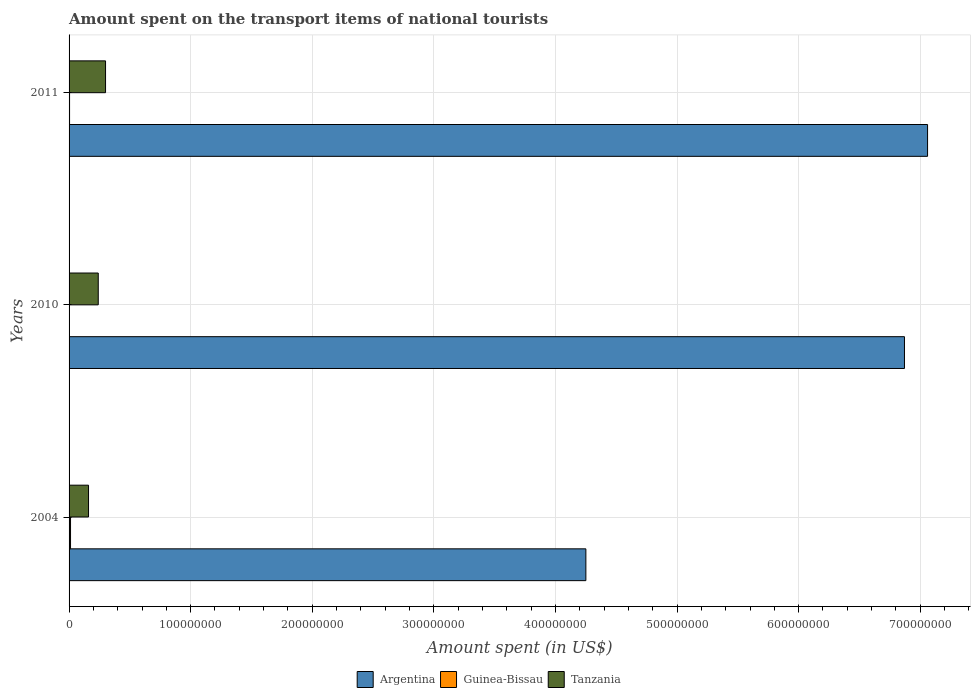How many different coloured bars are there?
Your answer should be compact. 3. Are the number of bars per tick equal to the number of legend labels?
Provide a short and direct response. Yes. Are the number of bars on each tick of the Y-axis equal?
Provide a short and direct response. Yes. How many bars are there on the 2nd tick from the top?
Keep it short and to the point. 3. What is the amount spent on the transport items of national tourists in Argentina in 2004?
Offer a terse response. 4.25e+08. Across all years, what is the maximum amount spent on the transport items of national tourists in Guinea-Bissau?
Your answer should be compact. 1.20e+06. Across all years, what is the minimum amount spent on the transport items of national tourists in Tanzania?
Your response must be concise. 1.60e+07. In which year was the amount spent on the transport items of national tourists in Argentina minimum?
Offer a terse response. 2004. What is the total amount spent on the transport items of national tourists in Guinea-Bissau in the graph?
Your response must be concise. 1.90e+06. What is the difference between the amount spent on the transport items of national tourists in Guinea-Bissau in 2004 and that in 2010?
Your response must be concise. 9.00e+05. What is the difference between the amount spent on the transport items of national tourists in Guinea-Bissau in 2010 and the amount spent on the transport items of national tourists in Tanzania in 2011?
Offer a terse response. -2.97e+07. What is the average amount spent on the transport items of national tourists in Guinea-Bissau per year?
Give a very brief answer. 6.33e+05. In the year 2004, what is the difference between the amount spent on the transport items of national tourists in Guinea-Bissau and amount spent on the transport items of national tourists in Argentina?
Your response must be concise. -4.24e+08. In how many years, is the amount spent on the transport items of national tourists in Argentina greater than 280000000 US$?
Provide a short and direct response. 3. What is the difference between the highest and the second highest amount spent on the transport items of national tourists in Argentina?
Provide a succinct answer. 1.90e+07. What is the difference between the highest and the lowest amount spent on the transport items of national tourists in Argentina?
Provide a short and direct response. 2.81e+08. In how many years, is the amount spent on the transport items of national tourists in Tanzania greater than the average amount spent on the transport items of national tourists in Tanzania taken over all years?
Offer a terse response. 2. Is the sum of the amount spent on the transport items of national tourists in Tanzania in 2004 and 2010 greater than the maximum amount spent on the transport items of national tourists in Argentina across all years?
Your response must be concise. No. What does the 2nd bar from the bottom in 2011 represents?
Your answer should be compact. Guinea-Bissau. Is it the case that in every year, the sum of the amount spent on the transport items of national tourists in Argentina and amount spent on the transport items of national tourists in Guinea-Bissau is greater than the amount spent on the transport items of national tourists in Tanzania?
Your answer should be compact. Yes. Are all the bars in the graph horizontal?
Keep it short and to the point. Yes. How many years are there in the graph?
Provide a succinct answer. 3. What is the difference between two consecutive major ticks on the X-axis?
Make the answer very short. 1.00e+08. Are the values on the major ticks of X-axis written in scientific E-notation?
Your answer should be compact. No. How many legend labels are there?
Provide a short and direct response. 3. What is the title of the graph?
Provide a short and direct response. Amount spent on the transport items of national tourists. Does "Zambia" appear as one of the legend labels in the graph?
Make the answer very short. No. What is the label or title of the X-axis?
Offer a very short reply. Amount spent (in US$). What is the Amount spent (in US$) in Argentina in 2004?
Provide a succinct answer. 4.25e+08. What is the Amount spent (in US$) of Guinea-Bissau in 2004?
Ensure brevity in your answer.  1.20e+06. What is the Amount spent (in US$) of Tanzania in 2004?
Your response must be concise. 1.60e+07. What is the Amount spent (in US$) of Argentina in 2010?
Keep it short and to the point. 6.87e+08. What is the Amount spent (in US$) of Tanzania in 2010?
Your answer should be compact. 2.40e+07. What is the Amount spent (in US$) in Argentina in 2011?
Offer a terse response. 7.06e+08. What is the Amount spent (in US$) of Tanzania in 2011?
Make the answer very short. 3.00e+07. Across all years, what is the maximum Amount spent (in US$) of Argentina?
Offer a terse response. 7.06e+08. Across all years, what is the maximum Amount spent (in US$) of Guinea-Bissau?
Make the answer very short. 1.20e+06. Across all years, what is the maximum Amount spent (in US$) of Tanzania?
Your response must be concise. 3.00e+07. Across all years, what is the minimum Amount spent (in US$) in Argentina?
Give a very brief answer. 4.25e+08. Across all years, what is the minimum Amount spent (in US$) of Tanzania?
Make the answer very short. 1.60e+07. What is the total Amount spent (in US$) in Argentina in the graph?
Your answer should be very brief. 1.82e+09. What is the total Amount spent (in US$) of Guinea-Bissau in the graph?
Your response must be concise. 1.90e+06. What is the total Amount spent (in US$) in Tanzania in the graph?
Offer a very short reply. 7.00e+07. What is the difference between the Amount spent (in US$) of Argentina in 2004 and that in 2010?
Your response must be concise. -2.62e+08. What is the difference between the Amount spent (in US$) of Tanzania in 2004 and that in 2010?
Your answer should be very brief. -8.00e+06. What is the difference between the Amount spent (in US$) of Argentina in 2004 and that in 2011?
Offer a terse response. -2.81e+08. What is the difference between the Amount spent (in US$) of Guinea-Bissau in 2004 and that in 2011?
Your answer should be very brief. 8.00e+05. What is the difference between the Amount spent (in US$) in Tanzania in 2004 and that in 2011?
Offer a terse response. -1.40e+07. What is the difference between the Amount spent (in US$) in Argentina in 2010 and that in 2011?
Keep it short and to the point. -1.90e+07. What is the difference between the Amount spent (in US$) of Guinea-Bissau in 2010 and that in 2011?
Ensure brevity in your answer.  -1.00e+05. What is the difference between the Amount spent (in US$) of Tanzania in 2010 and that in 2011?
Provide a short and direct response. -6.00e+06. What is the difference between the Amount spent (in US$) in Argentina in 2004 and the Amount spent (in US$) in Guinea-Bissau in 2010?
Your answer should be very brief. 4.25e+08. What is the difference between the Amount spent (in US$) in Argentina in 2004 and the Amount spent (in US$) in Tanzania in 2010?
Your answer should be very brief. 4.01e+08. What is the difference between the Amount spent (in US$) in Guinea-Bissau in 2004 and the Amount spent (in US$) in Tanzania in 2010?
Offer a very short reply. -2.28e+07. What is the difference between the Amount spent (in US$) of Argentina in 2004 and the Amount spent (in US$) of Guinea-Bissau in 2011?
Make the answer very short. 4.25e+08. What is the difference between the Amount spent (in US$) in Argentina in 2004 and the Amount spent (in US$) in Tanzania in 2011?
Make the answer very short. 3.95e+08. What is the difference between the Amount spent (in US$) in Guinea-Bissau in 2004 and the Amount spent (in US$) in Tanzania in 2011?
Make the answer very short. -2.88e+07. What is the difference between the Amount spent (in US$) of Argentina in 2010 and the Amount spent (in US$) of Guinea-Bissau in 2011?
Make the answer very short. 6.87e+08. What is the difference between the Amount spent (in US$) in Argentina in 2010 and the Amount spent (in US$) in Tanzania in 2011?
Make the answer very short. 6.57e+08. What is the difference between the Amount spent (in US$) in Guinea-Bissau in 2010 and the Amount spent (in US$) in Tanzania in 2011?
Keep it short and to the point. -2.97e+07. What is the average Amount spent (in US$) in Argentina per year?
Your answer should be compact. 6.06e+08. What is the average Amount spent (in US$) of Guinea-Bissau per year?
Offer a very short reply. 6.33e+05. What is the average Amount spent (in US$) in Tanzania per year?
Your response must be concise. 2.33e+07. In the year 2004, what is the difference between the Amount spent (in US$) in Argentina and Amount spent (in US$) in Guinea-Bissau?
Your response must be concise. 4.24e+08. In the year 2004, what is the difference between the Amount spent (in US$) of Argentina and Amount spent (in US$) of Tanzania?
Your answer should be very brief. 4.09e+08. In the year 2004, what is the difference between the Amount spent (in US$) of Guinea-Bissau and Amount spent (in US$) of Tanzania?
Make the answer very short. -1.48e+07. In the year 2010, what is the difference between the Amount spent (in US$) in Argentina and Amount spent (in US$) in Guinea-Bissau?
Keep it short and to the point. 6.87e+08. In the year 2010, what is the difference between the Amount spent (in US$) of Argentina and Amount spent (in US$) of Tanzania?
Provide a short and direct response. 6.63e+08. In the year 2010, what is the difference between the Amount spent (in US$) of Guinea-Bissau and Amount spent (in US$) of Tanzania?
Provide a short and direct response. -2.37e+07. In the year 2011, what is the difference between the Amount spent (in US$) in Argentina and Amount spent (in US$) in Guinea-Bissau?
Give a very brief answer. 7.06e+08. In the year 2011, what is the difference between the Amount spent (in US$) in Argentina and Amount spent (in US$) in Tanzania?
Your response must be concise. 6.76e+08. In the year 2011, what is the difference between the Amount spent (in US$) of Guinea-Bissau and Amount spent (in US$) of Tanzania?
Offer a terse response. -2.96e+07. What is the ratio of the Amount spent (in US$) in Argentina in 2004 to that in 2010?
Your answer should be compact. 0.62. What is the ratio of the Amount spent (in US$) of Guinea-Bissau in 2004 to that in 2010?
Your answer should be compact. 4. What is the ratio of the Amount spent (in US$) of Argentina in 2004 to that in 2011?
Offer a very short reply. 0.6. What is the ratio of the Amount spent (in US$) of Tanzania in 2004 to that in 2011?
Ensure brevity in your answer.  0.53. What is the ratio of the Amount spent (in US$) of Argentina in 2010 to that in 2011?
Provide a short and direct response. 0.97. What is the ratio of the Amount spent (in US$) of Guinea-Bissau in 2010 to that in 2011?
Give a very brief answer. 0.75. What is the difference between the highest and the second highest Amount spent (in US$) of Argentina?
Your response must be concise. 1.90e+07. What is the difference between the highest and the lowest Amount spent (in US$) in Argentina?
Ensure brevity in your answer.  2.81e+08. What is the difference between the highest and the lowest Amount spent (in US$) of Guinea-Bissau?
Give a very brief answer. 9.00e+05. What is the difference between the highest and the lowest Amount spent (in US$) in Tanzania?
Provide a succinct answer. 1.40e+07. 